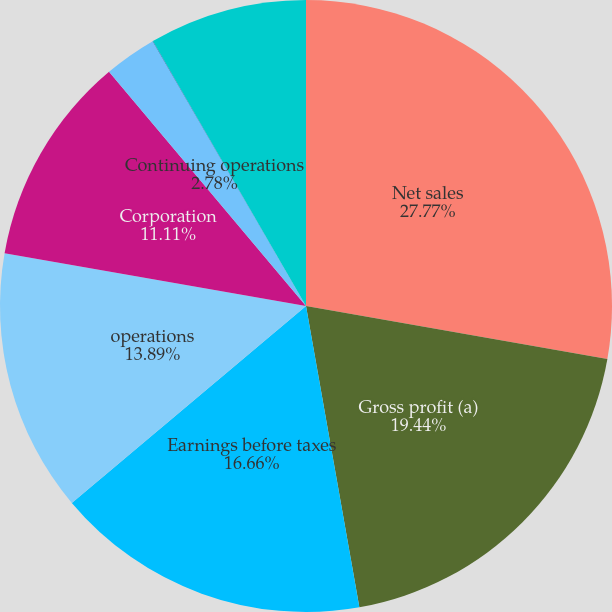Convert chart to OTSL. <chart><loc_0><loc_0><loc_500><loc_500><pie_chart><fcel>Net sales<fcel>Gross profit (a)<fcel>Earnings before taxes<fcel>operations<fcel>Corporation<fcel>Continuing operations<fcel>Total<fcel>Net earnings attributable to<nl><fcel>27.77%<fcel>19.44%<fcel>16.66%<fcel>13.89%<fcel>11.11%<fcel>2.78%<fcel>0.01%<fcel>8.34%<nl></chart> 